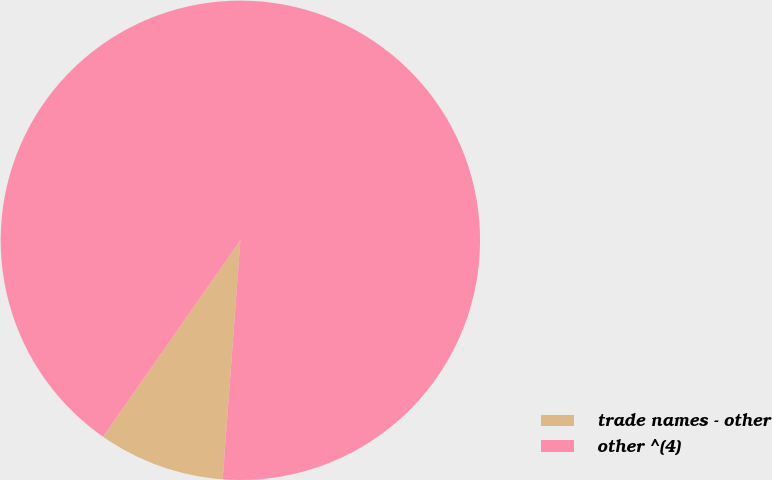Convert chart to OTSL. <chart><loc_0><loc_0><loc_500><loc_500><pie_chart><fcel>trade names - other<fcel>other ^(4)<nl><fcel>8.53%<fcel>91.47%<nl></chart> 